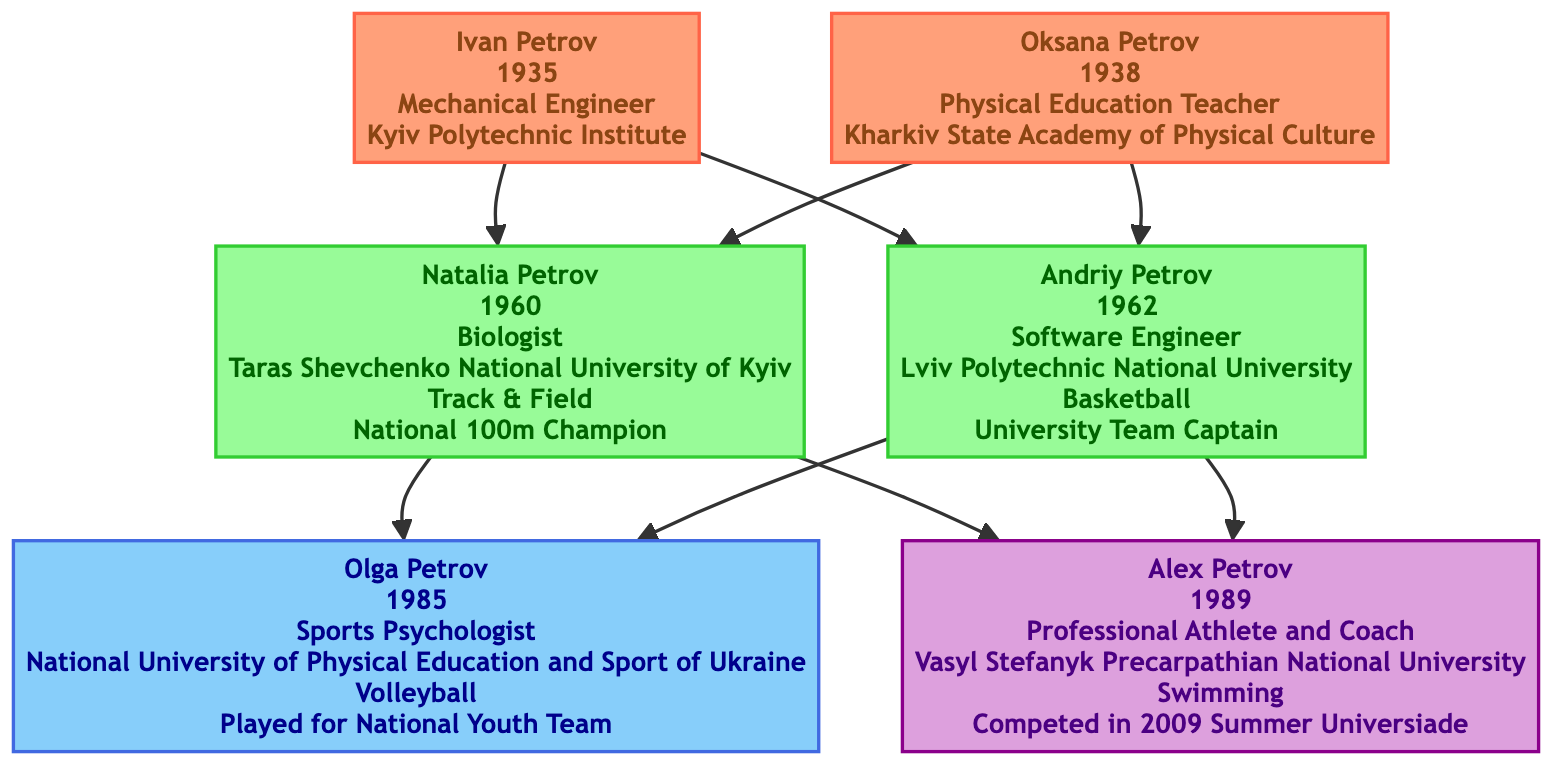What is the profession of Ivan Petrov? The diagram lists Ivan Petrov's profession as "Mechanical Engineer."
Answer: Mechanical Engineer Who is the youngest sibling in the family tree? The youngest sibling is Olga Petrov, who was born in 1985, making her younger than Alex Petrov (1989) and older than both parents.
Answer: Olga Petrov How many grandparents are represented in the tree? The diagram shows two grandparents: Ivan Petrov and Oksana Petrov. Therefore, the number of grandparents is two.
Answer: 2 What sport did Natalia Petrov compete in as an athlete? According to the diagram, Natalia Petrov was a competitor in "Track & Field."
Answer: Track & Field Which parent has a profession related to technology? The diagram indicates that Andriy Petrov is a "Software Engineer," which is a profession related to technology.
Answer: Software Engineer What is the achievement of Alex Petrov? In the diagram, Alex Petrov's achievement is listed as "Competed in 2009 Summer Universiade."
Answer: Competed in 2009 Summer Universiade What educational institution did Olga Petrov attend? The diagram states that Olga Petrov graduated from the "National University of Physical Education and Sport of Ukraine."
Answer: National University of Physical Education and Sport of Ukraine Which family member achieved national champion status? The diagram states that Natalia Petrov achieved the status of "National 100m Champion" in track and field.
Answer: National 100m Champion What degree did Andriy Petrov obtain? The diagram indicates that he obtained his education at "Lviv Polytechnic National University."
Answer: Lviv Polytechnic National University 